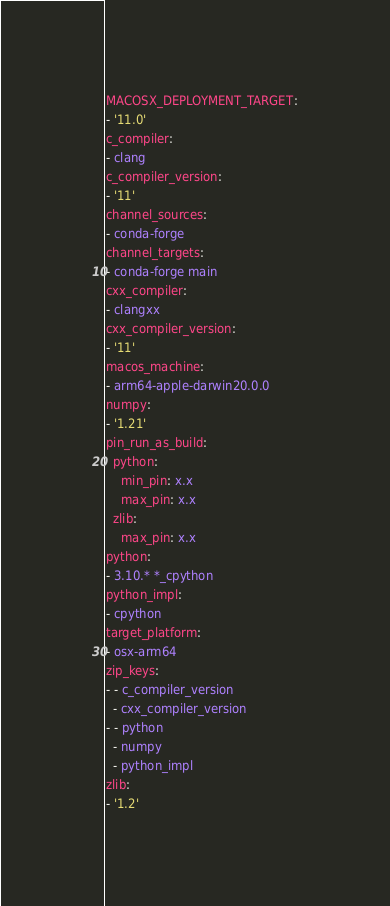Convert code to text. <code><loc_0><loc_0><loc_500><loc_500><_YAML_>MACOSX_DEPLOYMENT_TARGET:
- '11.0'
c_compiler:
- clang
c_compiler_version:
- '11'
channel_sources:
- conda-forge
channel_targets:
- conda-forge main
cxx_compiler:
- clangxx
cxx_compiler_version:
- '11'
macos_machine:
- arm64-apple-darwin20.0.0
numpy:
- '1.21'
pin_run_as_build:
  python:
    min_pin: x.x
    max_pin: x.x
  zlib:
    max_pin: x.x
python:
- 3.10.* *_cpython
python_impl:
- cpython
target_platform:
- osx-arm64
zip_keys:
- - c_compiler_version
  - cxx_compiler_version
- - python
  - numpy
  - python_impl
zlib:
- '1.2'
</code> 